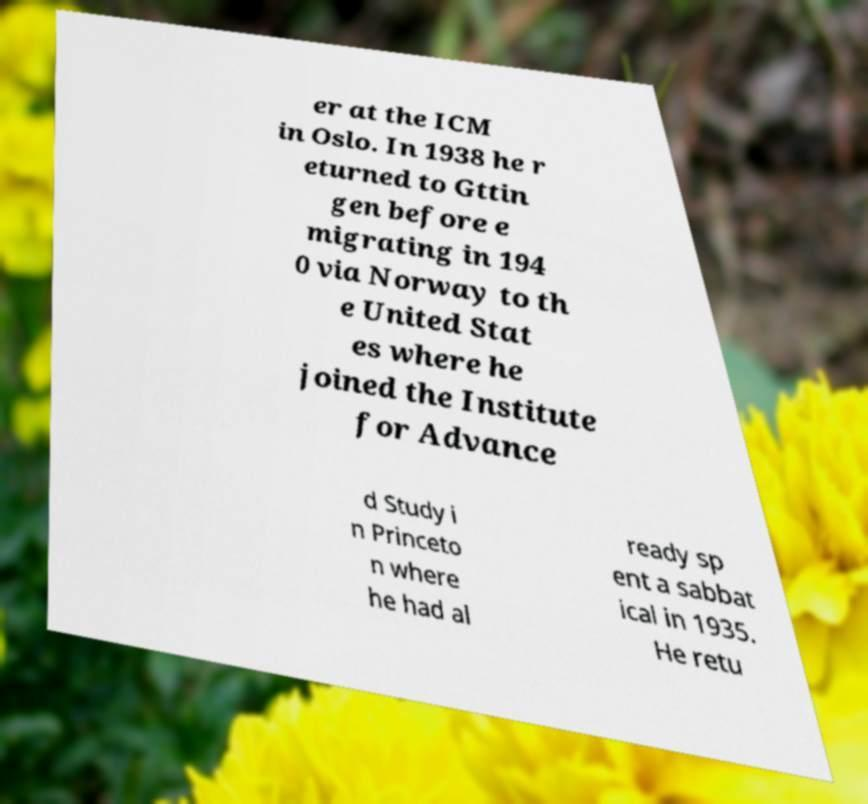What messages or text are displayed in this image? I need them in a readable, typed format. er at the ICM in Oslo. In 1938 he r eturned to Gttin gen before e migrating in 194 0 via Norway to th e United Stat es where he joined the Institute for Advance d Study i n Princeto n where he had al ready sp ent a sabbat ical in 1935. He retu 